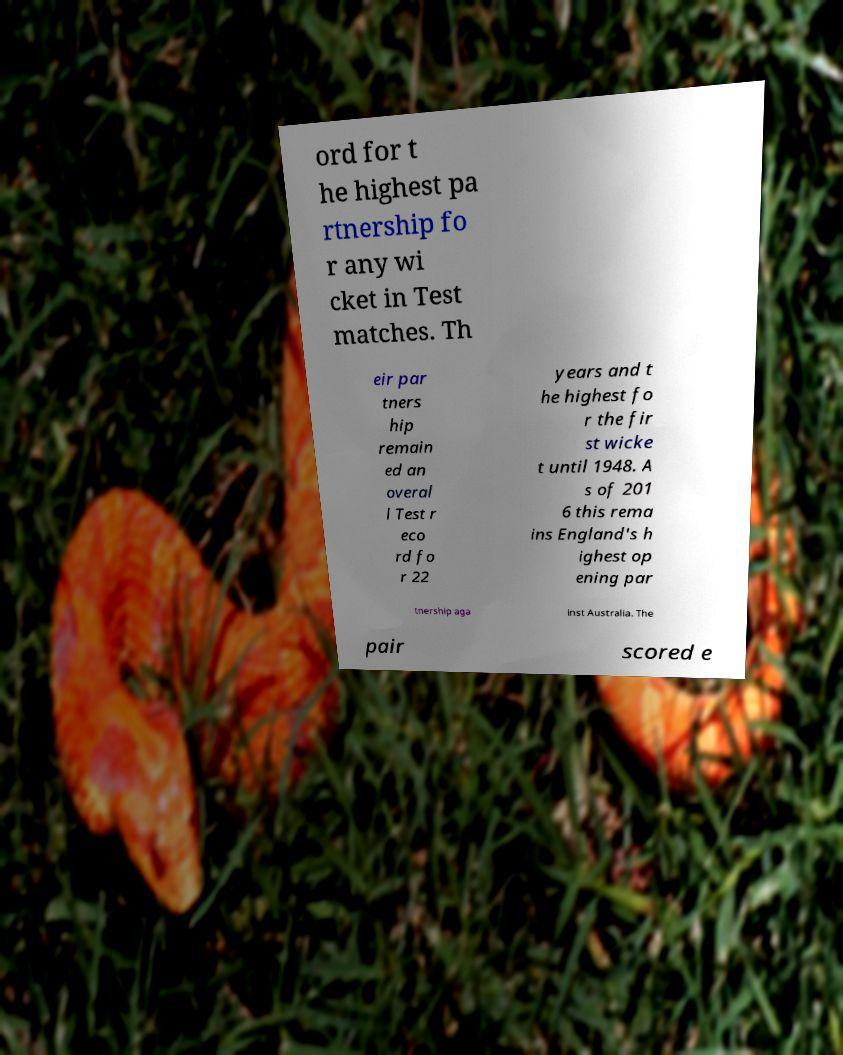Can you read and provide the text displayed in the image?This photo seems to have some interesting text. Can you extract and type it out for me? ord for t he highest pa rtnership fo r any wi cket in Test matches. Th eir par tners hip remain ed an overal l Test r eco rd fo r 22 years and t he highest fo r the fir st wicke t until 1948. A s of 201 6 this rema ins England's h ighest op ening par tnership aga inst Australia. The pair scored e 